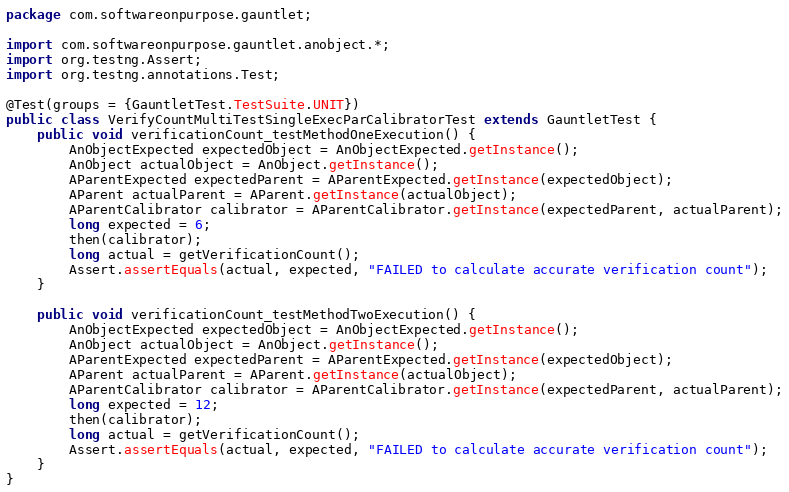<code> <loc_0><loc_0><loc_500><loc_500><_Java_>package com.softwareonpurpose.gauntlet;

import com.softwareonpurpose.gauntlet.anobject.*;
import org.testng.Assert;
import org.testng.annotations.Test;

@Test(groups = {GauntletTest.TestSuite.UNIT})
public class VerifyCountMultiTestSingleExecParCalibratorTest extends GauntletTest {
    public void verificationCount_testMethodOneExecution() {
        AnObjectExpected expectedObject = AnObjectExpected.getInstance();
        AnObject actualObject = AnObject.getInstance();
        AParentExpected expectedParent = AParentExpected.getInstance(expectedObject);
        AParent actualParent = AParent.getInstance(actualObject);
        AParentCalibrator calibrator = AParentCalibrator.getInstance(expectedParent, actualParent);
        long expected = 6;
        then(calibrator);
        long actual = getVerificationCount();
        Assert.assertEquals(actual, expected, "FAILED to calculate accurate verification count");
    }

    public void verificationCount_testMethodTwoExecution() {
        AnObjectExpected expectedObject = AnObjectExpected.getInstance();
        AnObject actualObject = AnObject.getInstance();
        AParentExpected expectedParent = AParentExpected.getInstance(expectedObject);
        AParent actualParent = AParent.getInstance(actualObject);
        AParentCalibrator calibrator = AParentCalibrator.getInstance(expectedParent, actualParent);
        long expected = 12;
        then(calibrator);
        long actual = getVerificationCount();
        Assert.assertEquals(actual, expected, "FAILED to calculate accurate verification count");
    }
}
</code> 